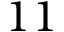<formula> <loc_0><loc_0><loc_500><loc_500>1 1</formula> 